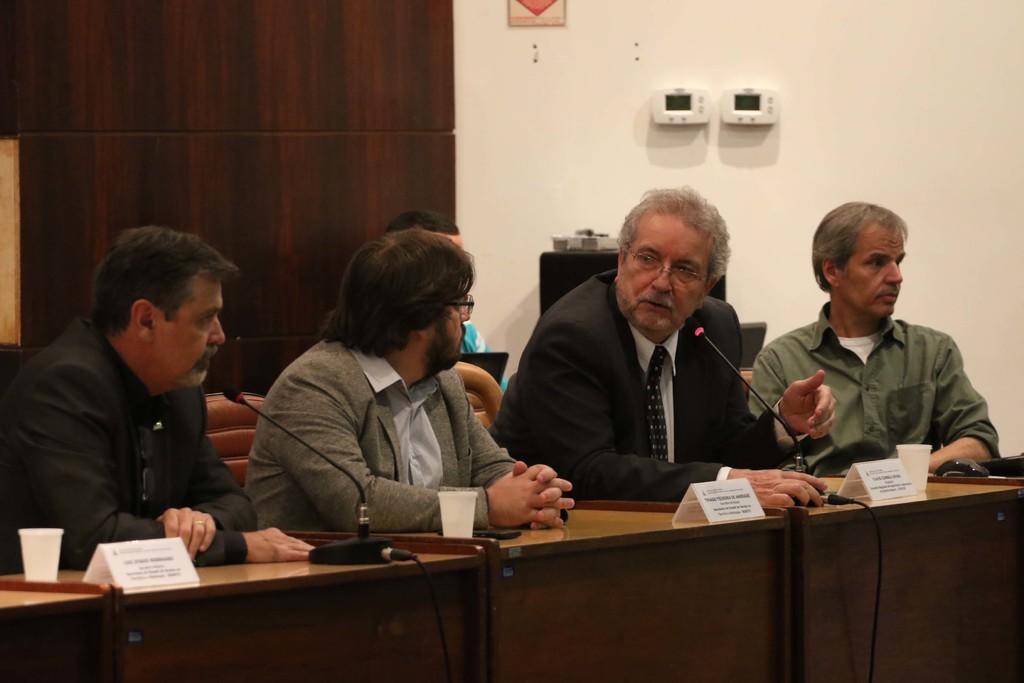Please provide a concise description of this image. At the bottom of the image there is a table, on the table there are some cups and microphones. Behind the table few people are sitting. At the top of the image there is a wall. 